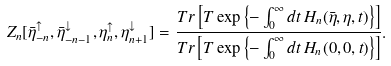Convert formula to latex. <formula><loc_0><loc_0><loc_500><loc_500>Z _ { n } [ \bar { \eta } _ { - n } ^ { \uparrow } , \bar { \eta } _ { - n - 1 } ^ { \downarrow } , \eta _ { n } ^ { \uparrow } , \eta _ { n + 1 } ^ { \downarrow } ] = \frac { T r \left [ T \exp \left \{ - \int _ { 0 } ^ { \infty } d t \, H _ { n } ( \bar { \eta } , \eta , t ) \right \} \right ] } { T r \left [ T \exp \left \{ - \int _ { 0 } ^ { \infty } d t \, H _ { n } ( 0 , 0 , t ) \right \} \right ] } .</formula> 